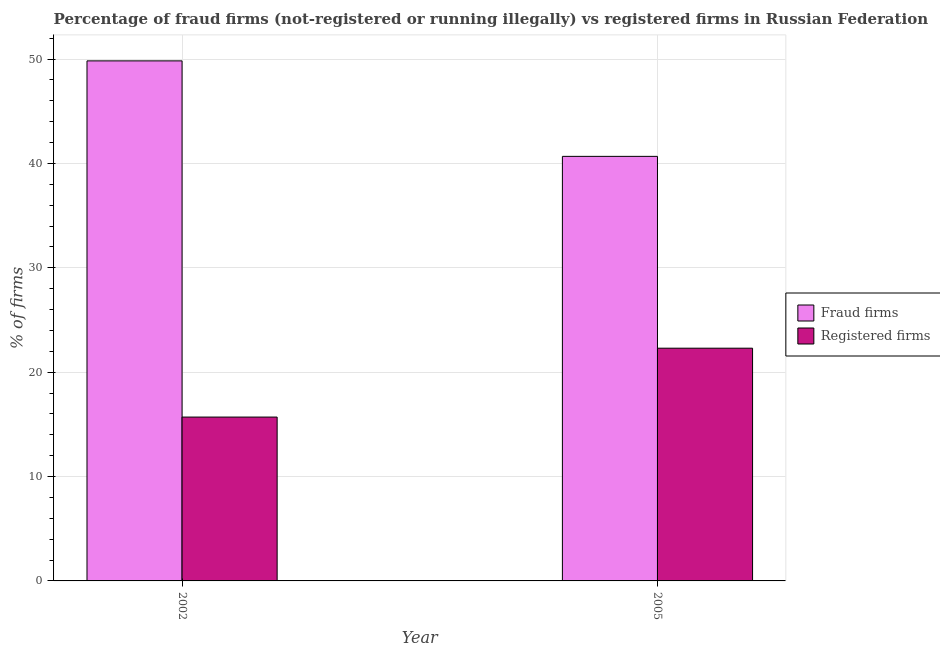How many groups of bars are there?
Ensure brevity in your answer.  2. Are the number of bars per tick equal to the number of legend labels?
Give a very brief answer. Yes. Are the number of bars on each tick of the X-axis equal?
Provide a succinct answer. Yes. How many bars are there on the 1st tick from the left?
Offer a terse response. 2. How many bars are there on the 2nd tick from the right?
Keep it short and to the point. 2. What is the percentage of registered firms in 2005?
Your response must be concise. 22.3. Across all years, what is the maximum percentage of fraud firms?
Offer a terse response. 49.83. Across all years, what is the minimum percentage of fraud firms?
Your response must be concise. 40.68. In which year was the percentage of fraud firms minimum?
Keep it short and to the point. 2005. What is the total percentage of registered firms in the graph?
Give a very brief answer. 38. What is the difference between the percentage of fraud firms in 2002 and that in 2005?
Offer a very short reply. 9.15. What is the difference between the percentage of registered firms in 2005 and the percentage of fraud firms in 2002?
Your answer should be compact. 6.6. What is the average percentage of registered firms per year?
Keep it short and to the point. 19. In the year 2005, what is the difference between the percentage of fraud firms and percentage of registered firms?
Offer a very short reply. 0. In how many years, is the percentage of registered firms greater than 32 %?
Give a very brief answer. 0. What is the ratio of the percentage of fraud firms in 2002 to that in 2005?
Your response must be concise. 1.22. In how many years, is the percentage of registered firms greater than the average percentage of registered firms taken over all years?
Provide a short and direct response. 1. What does the 1st bar from the left in 2005 represents?
Keep it short and to the point. Fraud firms. What does the 2nd bar from the right in 2002 represents?
Offer a terse response. Fraud firms. Are all the bars in the graph horizontal?
Give a very brief answer. No. How many years are there in the graph?
Ensure brevity in your answer.  2. Are the values on the major ticks of Y-axis written in scientific E-notation?
Provide a short and direct response. No. Does the graph contain grids?
Your answer should be compact. Yes. What is the title of the graph?
Offer a terse response. Percentage of fraud firms (not-registered or running illegally) vs registered firms in Russian Federation. Does "Current education expenditure" appear as one of the legend labels in the graph?
Your answer should be very brief. No. What is the label or title of the Y-axis?
Offer a very short reply. % of firms. What is the % of firms of Fraud firms in 2002?
Ensure brevity in your answer.  49.83. What is the % of firms in Fraud firms in 2005?
Give a very brief answer. 40.68. What is the % of firms in Registered firms in 2005?
Make the answer very short. 22.3. Across all years, what is the maximum % of firms in Fraud firms?
Give a very brief answer. 49.83. Across all years, what is the maximum % of firms in Registered firms?
Your response must be concise. 22.3. Across all years, what is the minimum % of firms of Fraud firms?
Offer a terse response. 40.68. Across all years, what is the minimum % of firms of Registered firms?
Keep it short and to the point. 15.7. What is the total % of firms of Fraud firms in the graph?
Provide a succinct answer. 90.51. What is the difference between the % of firms in Fraud firms in 2002 and that in 2005?
Provide a succinct answer. 9.15. What is the difference between the % of firms of Registered firms in 2002 and that in 2005?
Your answer should be compact. -6.6. What is the difference between the % of firms in Fraud firms in 2002 and the % of firms in Registered firms in 2005?
Give a very brief answer. 27.53. What is the average % of firms of Fraud firms per year?
Provide a succinct answer. 45.26. What is the average % of firms of Registered firms per year?
Your answer should be compact. 19. In the year 2002, what is the difference between the % of firms in Fraud firms and % of firms in Registered firms?
Give a very brief answer. 34.13. In the year 2005, what is the difference between the % of firms in Fraud firms and % of firms in Registered firms?
Ensure brevity in your answer.  18.38. What is the ratio of the % of firms of Fraud firms in 2002 to that in 2005?
Keep it short and to the point. 1.22. What is the ratio of the % of firms in Registered firms in 2002 to that in 2005?
Your answer should be very brief. 0.7. What is the difference between the highest and the second highest % of firms of Fraud firms?
Your response must be concise. 9.15. What is the difference between the highest and the second highest % of firms of Registered firms?
Offer a terse response. 6.6. What is the difference between the highest and the lowest % of firms in Fraud firms?
Offer a terse response. 9.15. What is the difference between the highest and the lowest % of firms of Registered firms?
Your answer should be compact. 6.6. 